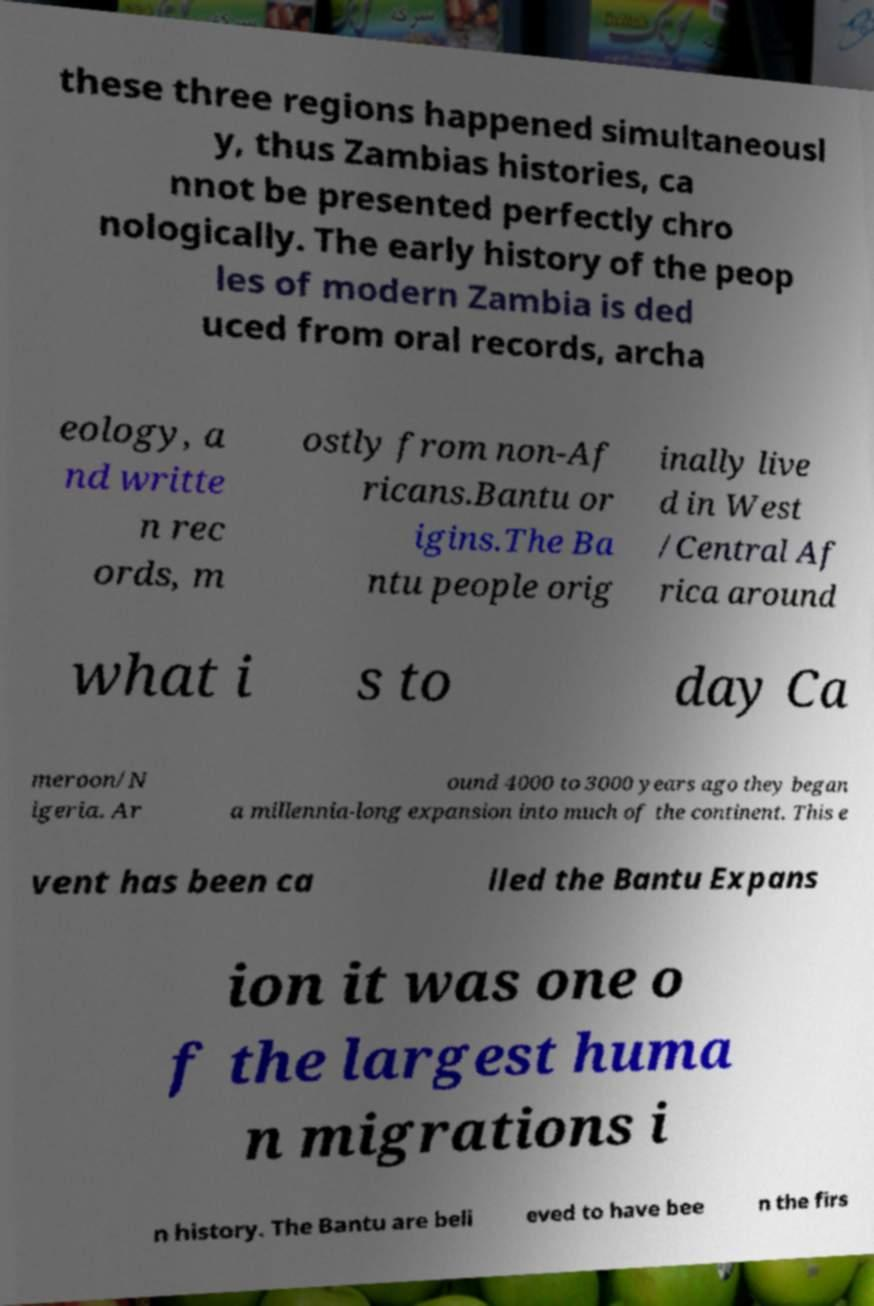Can you read and provide the text displayed in the image?This photo seems to have some interesting text. Can you extract and type it out for me? these three regions happened simultaneousl y, thus Zambias histories, ca nnot be presented perfectly chro nologically. The early history of the peop les of modern Zambia is ded uced from oral records, archa eology, a nd writte n rec ords, m ostly from non-Af ricans.Bantu or igins.The Ba ntu people orig inally live d in West /Central Af rica around what i s to day Ca meroon/N igeria. Ar ound 4000 to 3000 years ago they began a millennia-long expansion into much of the continent. This e vent has been ca lled the Bantu Expans ion it was one o f the largest huma n migrations i n history. The Bantu are beli eved to have bee n the firs 